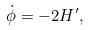<formula> <loc_0><loc_0><loc_500><loc_500>\dot { \phi } = - 2 H ^ { \prime } ,</formula> 